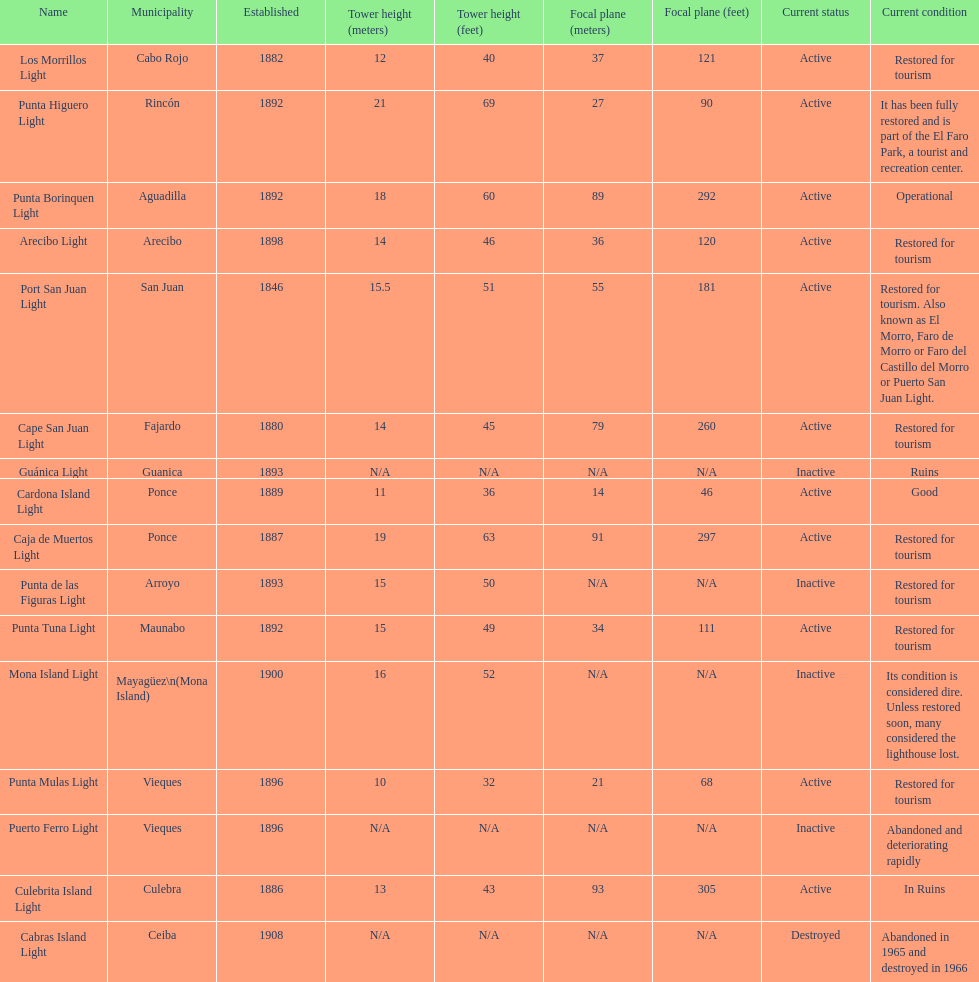Would you mind parsing the complete table? {'header': ['Name', 'Municipality', 'Established', 'Tower height (meters)', 'Tower height (feet)', 'Focal plane (meters)', 'Focal plane (feet)', 'Current status', 'Current condition'], 'rows': [['Los Morrillos Light', 'Cabo Rojo', '1882', '12', '40', '37', '121', 'Active', 'Restored for tourism'], ['Punta Higuero Light', 'Rincón', '1892', '21', '69', '27', '90', 'Active', 'It has been fully restored and is part of the El Faro Park, a tourist and recreation center.'], ['Punta Borinquen Light', 'Aguadilla', '1892', '18', '60', '89', '292', 'Active', 'Operational'], ['Arecibo Light', 'Arecibo', '1898', '14', '46', '36', '120', 'Active', 'Restored for tourism'], ['Port San Juan Light', 'San Juan', '1846', '15.5', '51', '55', '181', 'Active', 'Restored for tourism. Also known as El Morro, Faro de Morro or Faro del Castillo del Morro or Puerto San Juan Light.'], ['Cape San Juan Light', 'Fajardo', '1880', '14', '45', '79', '260', 'Active', 'Restored for tourism'], ['Guánica Light', 'Guanica', '1893', 'N/A', 'N/A', 'N/A', 'N/A', 'Inactive', 'Ruins'], ['Cardona Island Light', 'Ponce', '1889', '11', '36', '14', '46', 'Active', 'Good'], ['Caja de Muertos Light', 'Ponce', '1887', '19', '63', '91', '297', 'Active', 'Restored for tourism'], ['Punta de las Figuras Light', 'Arroyo', '1893', '15', '50', 'N/A', 'N/A', 'Inactive', 'Restored for tourism'], ['Punta Tuna Light', 'Maunabo', '1892', '15', '49', '34', '111', 'Active', 'Restored for tourism'], ['Mona Island Light', 'Mayagüez\\n(Mona Island)', '1900', '16', '52', 'N/A', 'N/A', 'Inactive', 'Its condition is considered dire. Unless restored soon, many considered the lighthouse lost.'], ['Punta Mulas Light', 'Vieques', '1896', '10', '32', '21', '68', 'Active', 'Restored for tourism'], ['Puerto Ferro Light', 'Vieques', '1896', 'N/A', 'N/A', 'N/A', 'N/A', 'Inactive', 'Abandoned and deteriorating rapidly'], ['Culebrita Island Light', 'Culebra', '1886', '13', '43', '93', '305', 'Active', 'In Ruins'], ['Cabras Island Light', 'Ceiba', '1908', 'N/A', 'N/A', 'N/A', 'N/A', 'Destroyed', 'Abandoned in 1965 and destroyed in 1966']]} Which municipality was the first to be established? San Juan. 